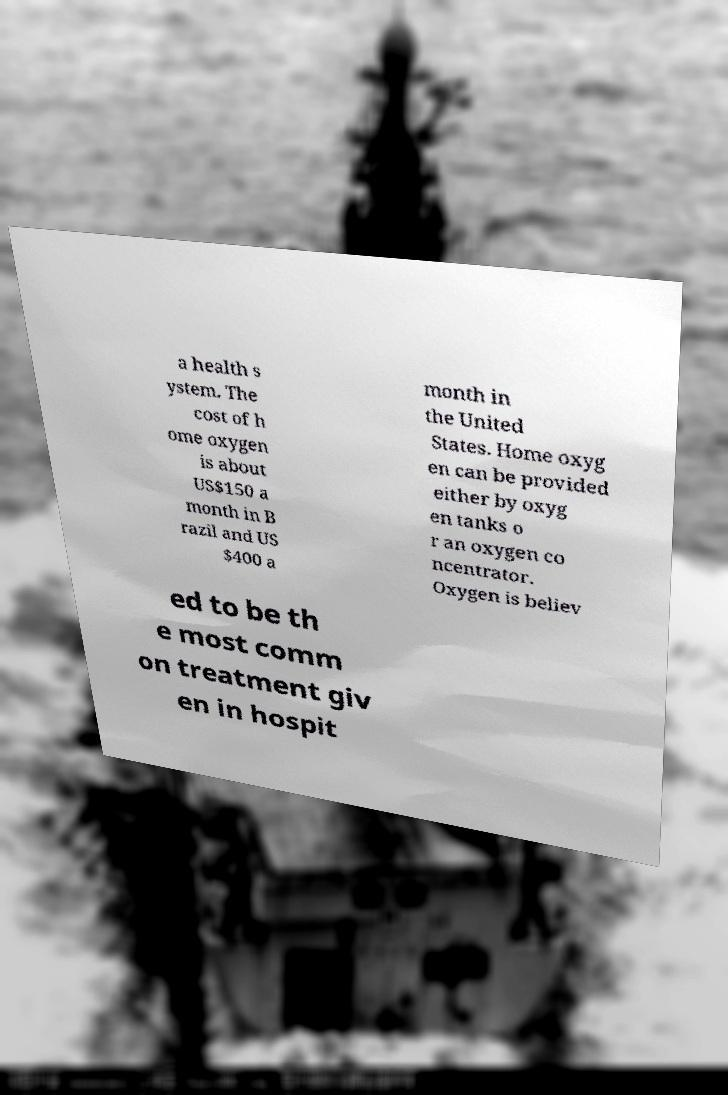Could you assist in decoding the text presented in this image and type it out clearly? a health s ystem. The cost of h ome oxygen is about US$150 a month in B razil and US $400 a month in the United States. Home oxyg en can be provided either by oxyg en tanks o r an oxygen co ncentrator. Oxygen is believ ed to be th e most comm on treatment giv en in hospit 